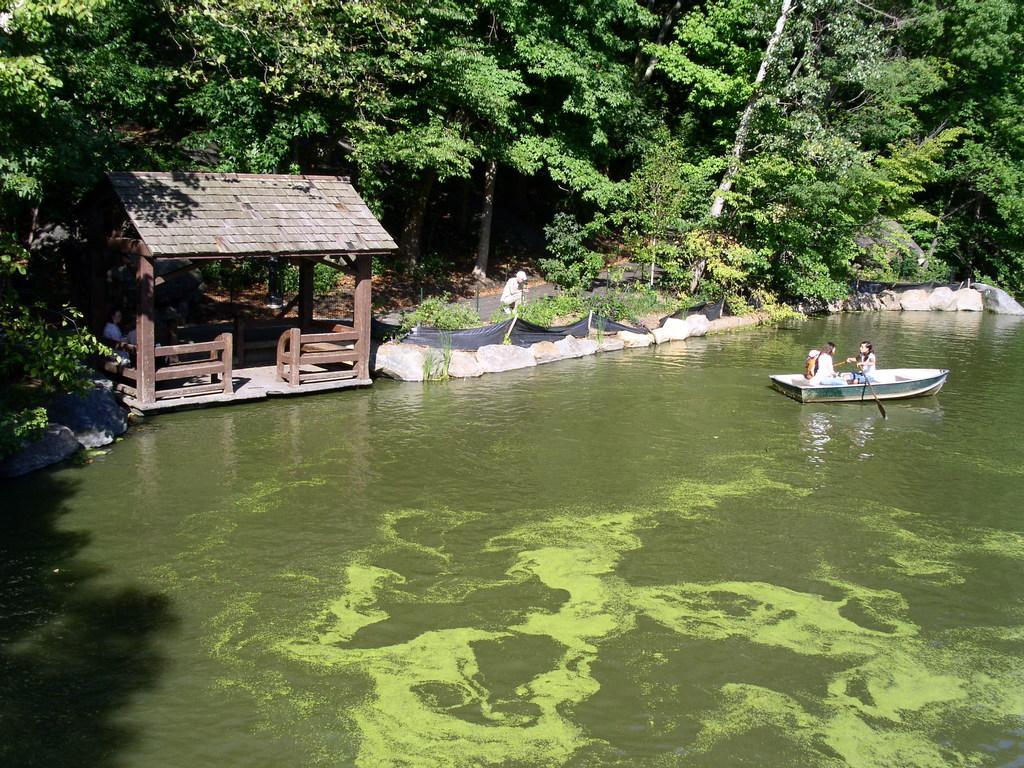How would you summarize this image in a sentence or two? In this picture we can see water, people in a boat and trees. A person is standing. 